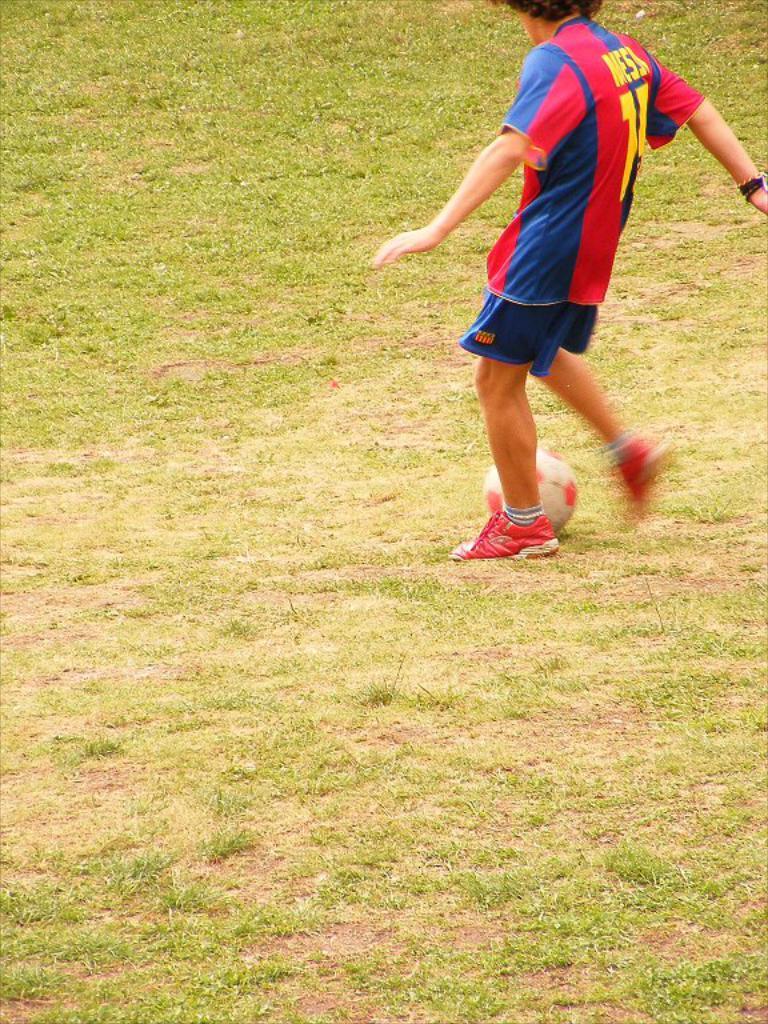What is the number on his jersey?
Make the answer very short. 14. 